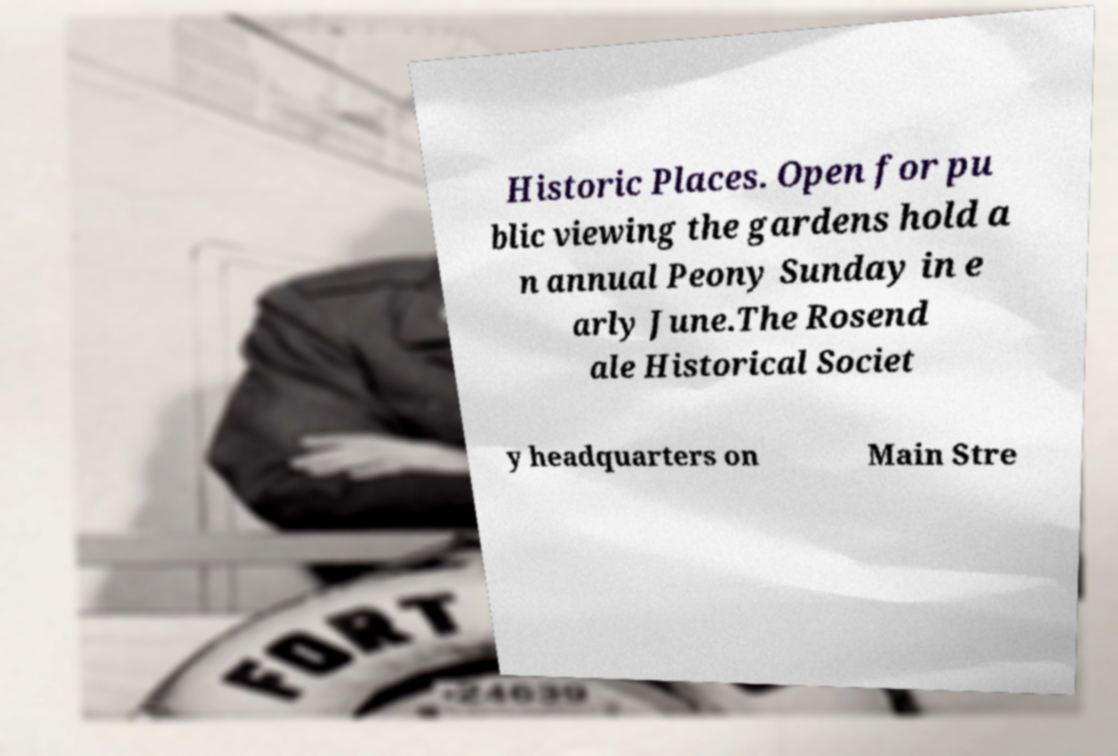I need the written content from this picture converted into text. Can you do that? Historic Places. Open for pu blic viewing the gardens hold a n annual Peony Sunday in e arly June.The Rosend ale Historical Societ y headquarters on Main Stre 